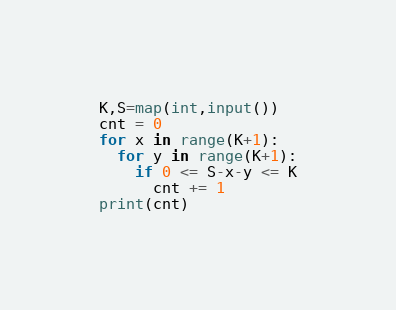<code> <loc_0><loc_0><loc_500><loc_500><_Python_>K,S=map(int,input())
cnt = 0
for x in range(K+1):
  for y in range(K+1):
    if 0 <= S-x-y <= K
      cnt += 1
print(cnt)
</code> 